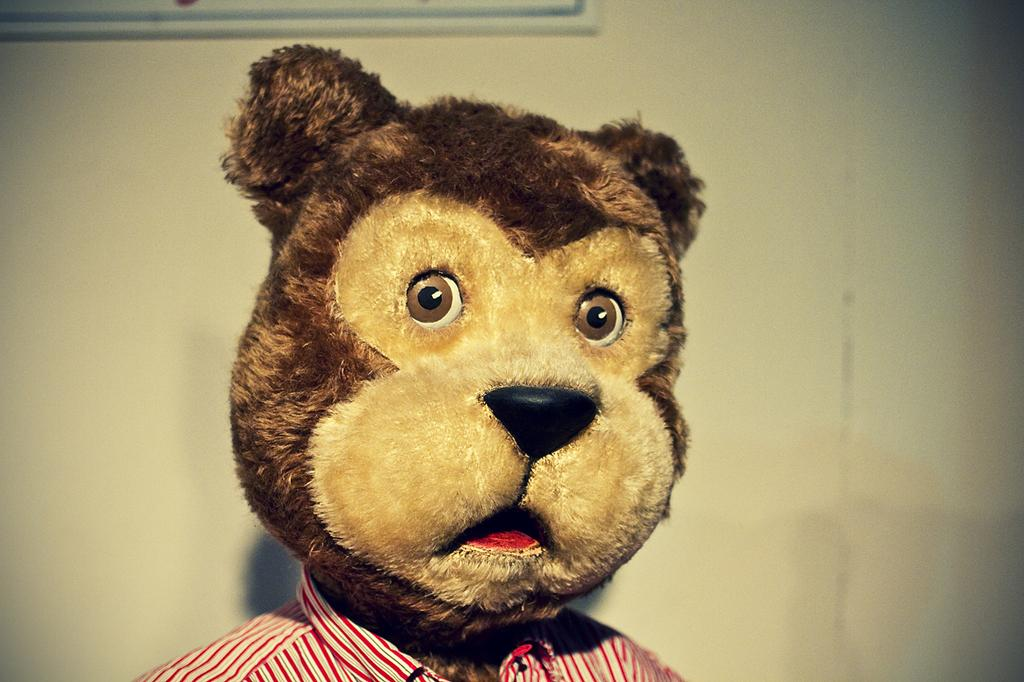What is the main subject in the foreground of the image? There is a teddy bear in the foreground of the image. Can you describe anything in the background of the image? There may be a wall in the background of the image. How much blood can be seen on the teddy bear in the image? There is no blood visible on the teddy bear in the image. How many men are present in the image? There is no information about men in the image, as the facts only mention a teddy bear and a possible wall in the background. 